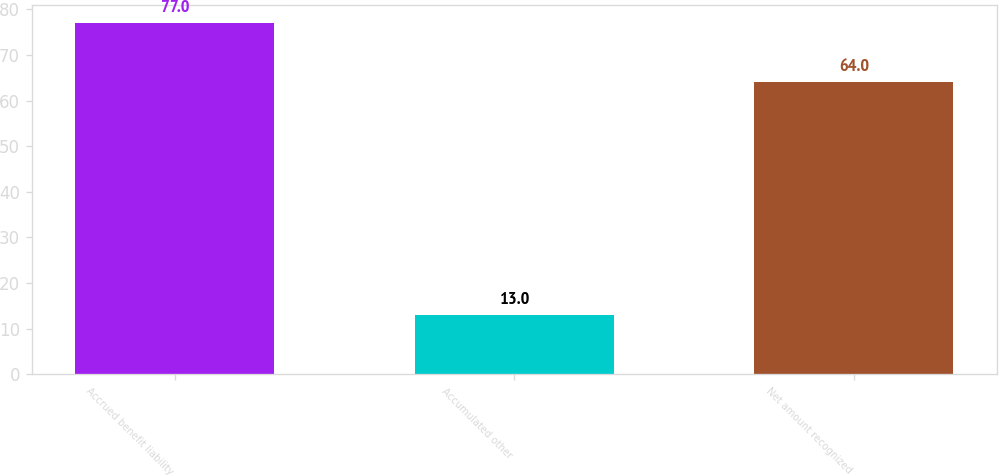Convert chart. <chart><loc_0><loc_0><loc_500><loc_500><bar_chart><fcel>Accrued benefit liability<fcel>Accumulated other<fcel>Net amount recognized<nl><fcel>77<fcel>13<fcel>64<nl></chart> 